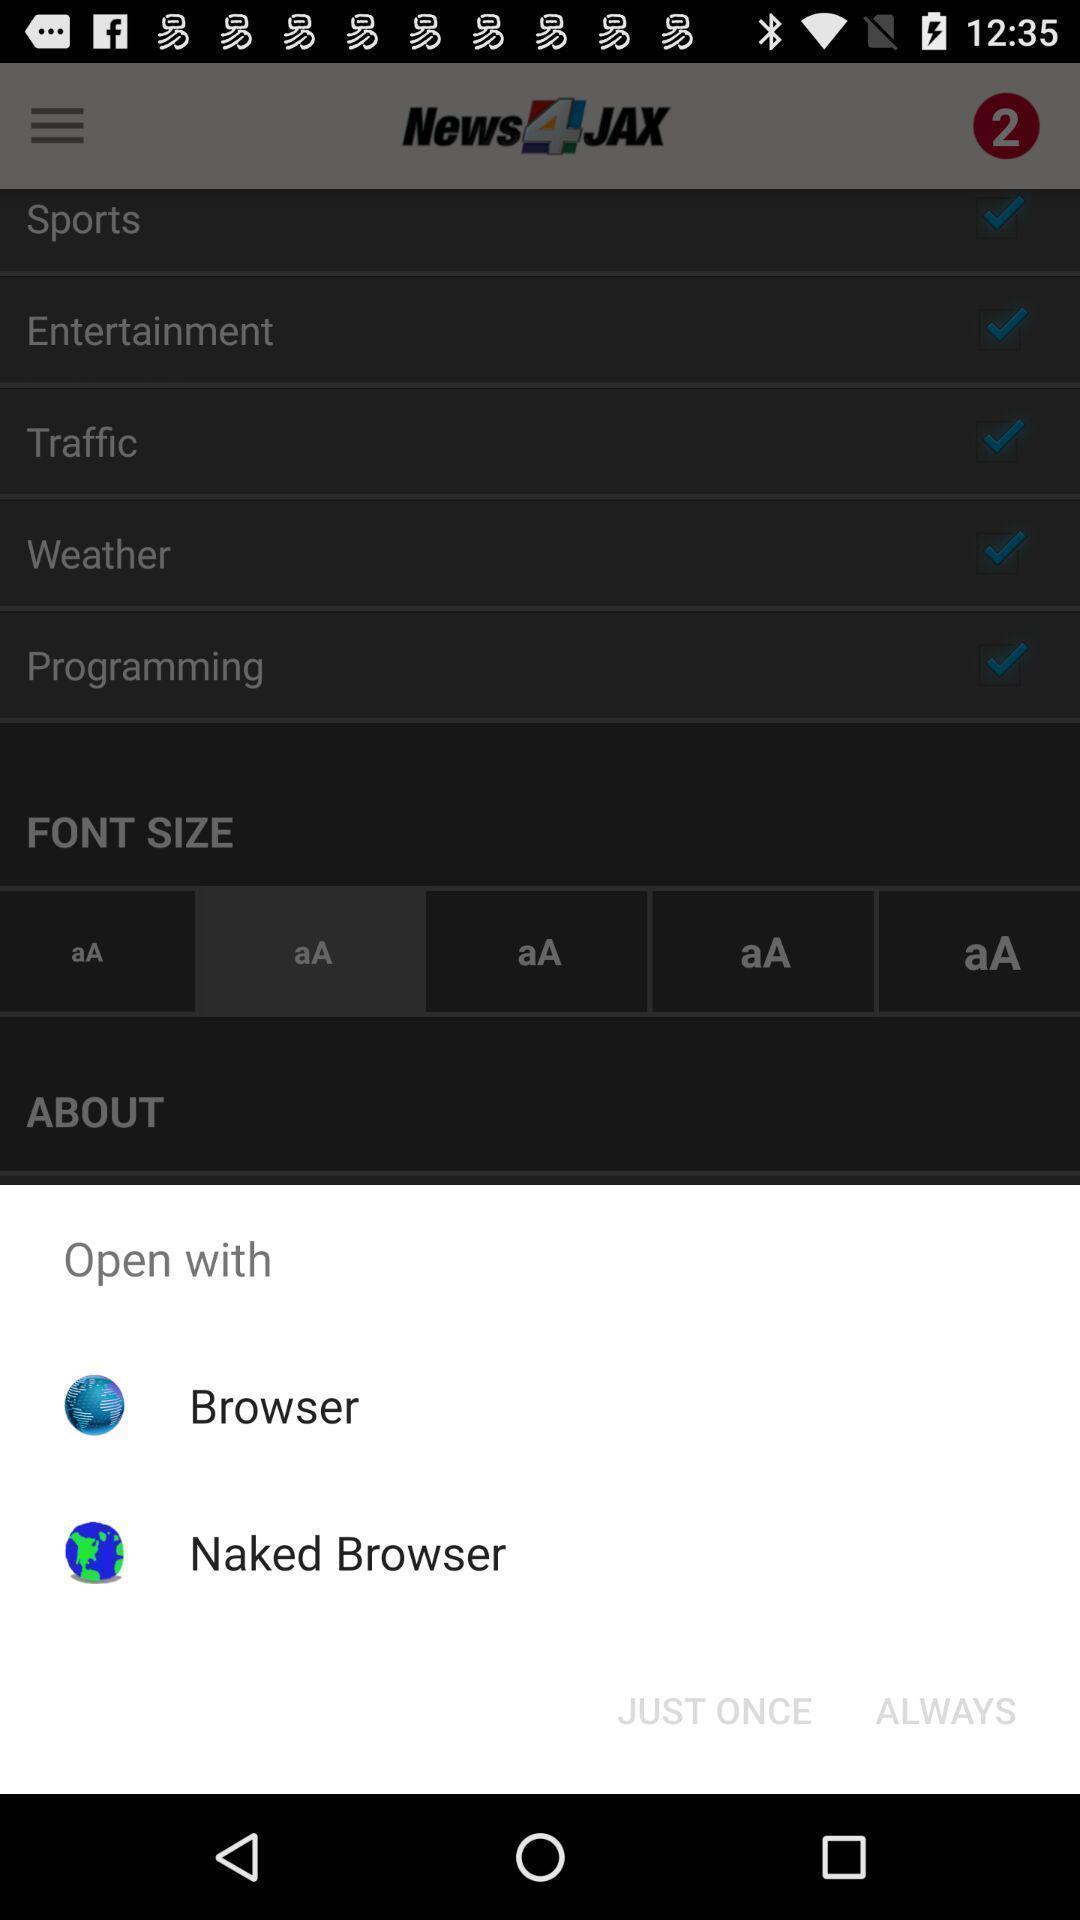Give me a narrative description of this picture. Pop-up displaying to open an app. 